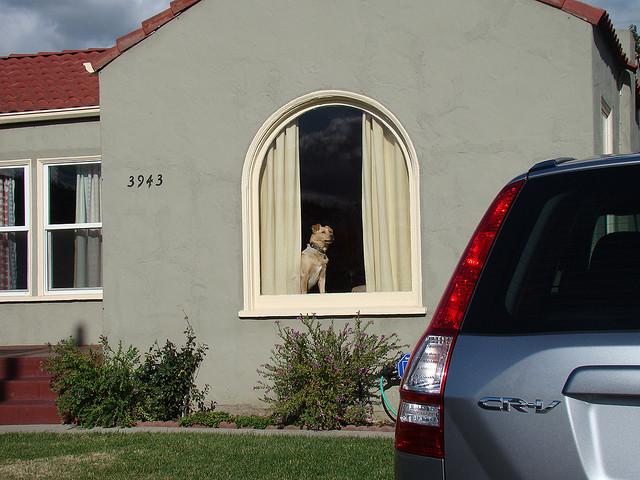What animal is in the window?
Give a very brief answer. Dog. What are the number on the house?
Write a very short answer. 3943. What kind of vehicle is parked outside of the house?
Write a very short answer. Crv. 